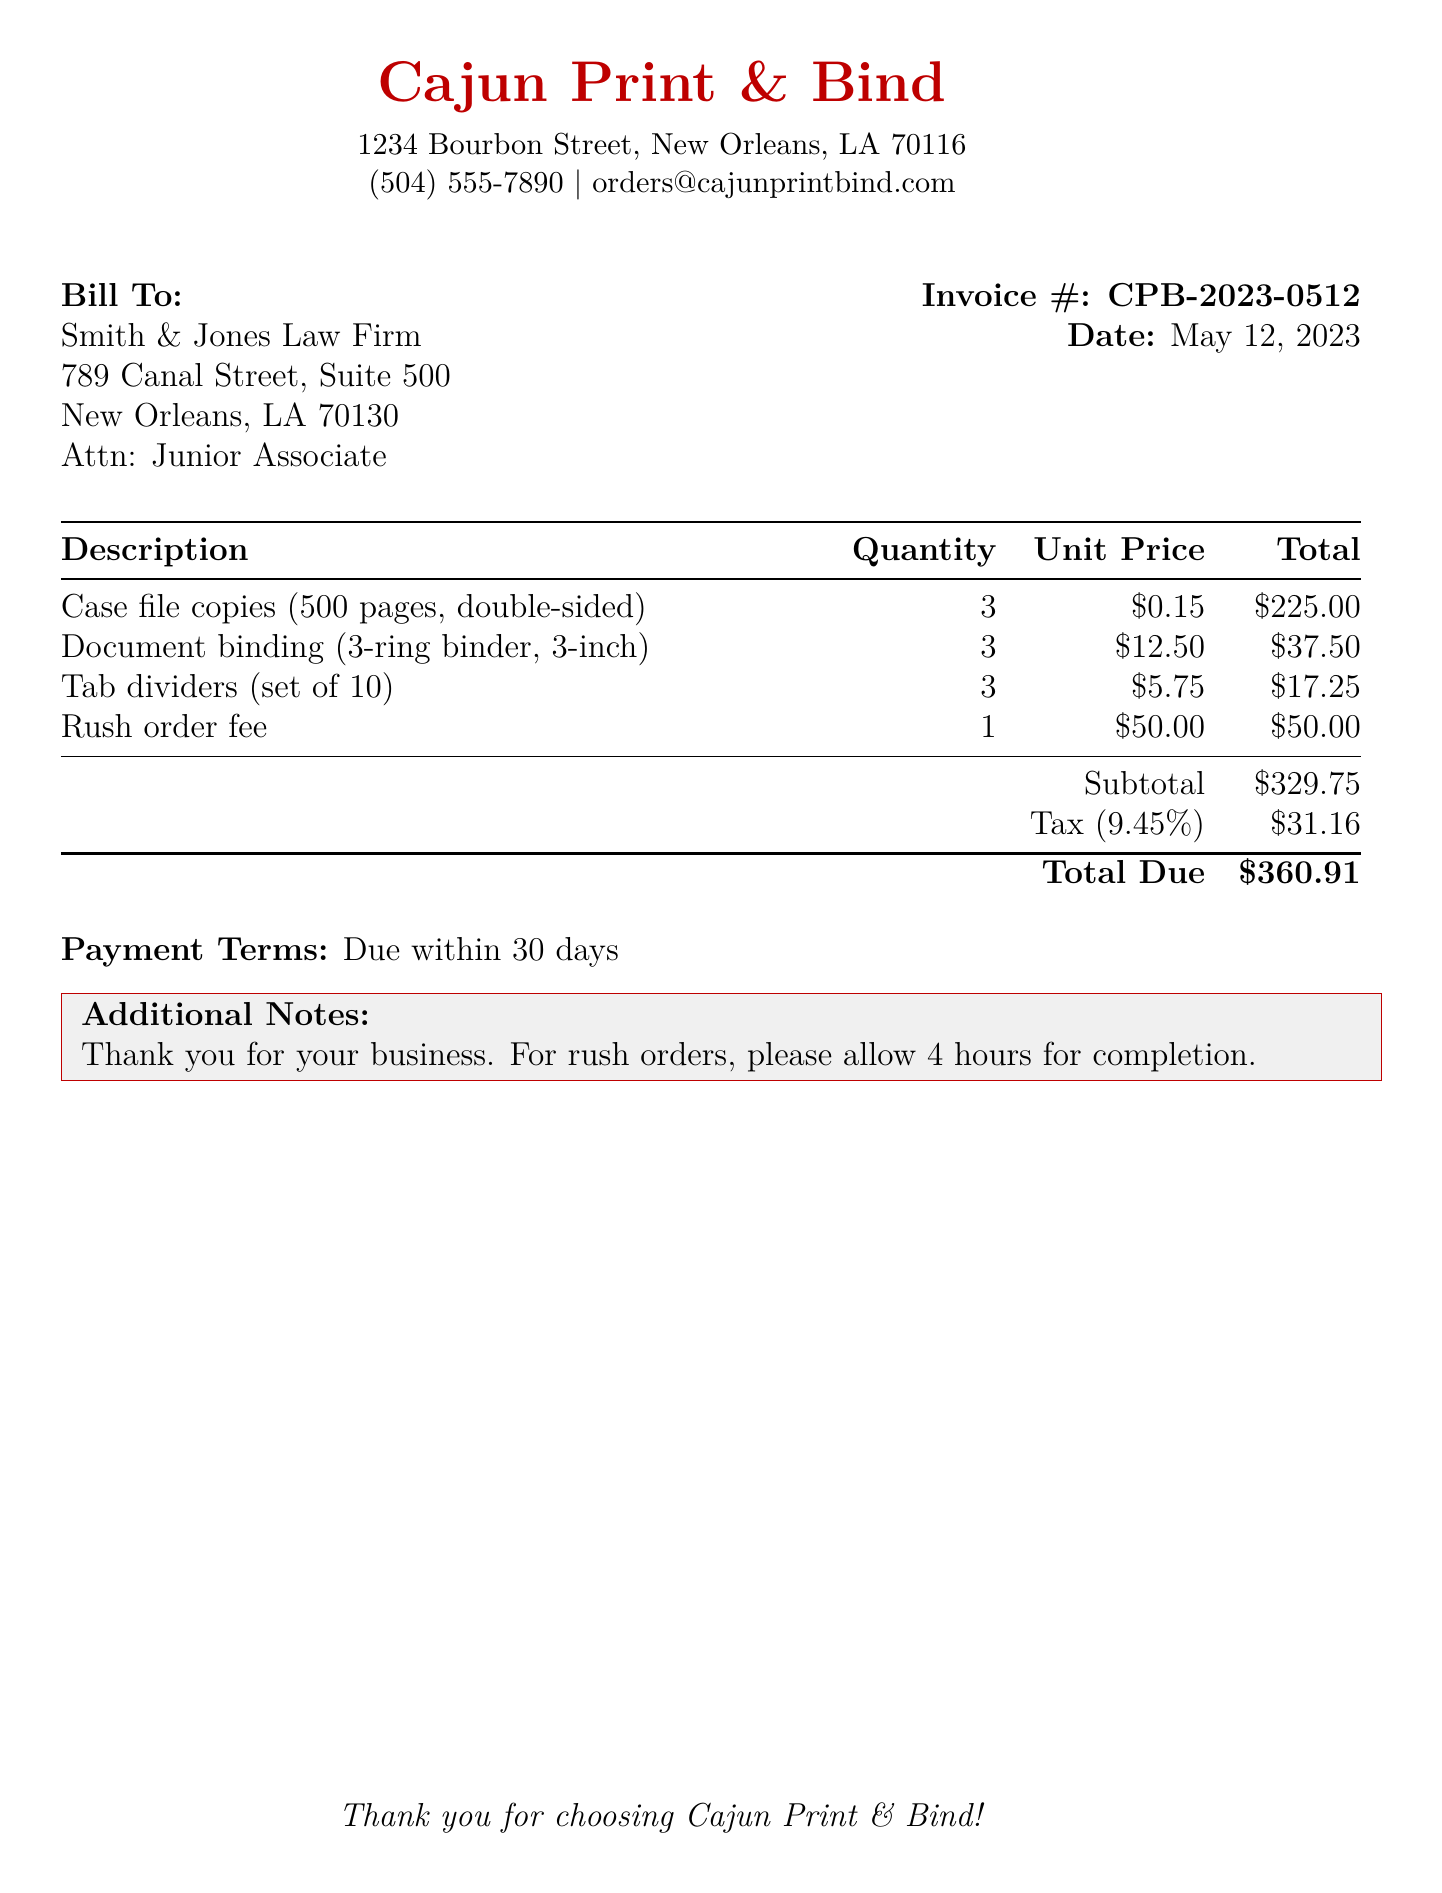what is the invoice number? The invoice number is listed at the top of the bill under "Invoice #."
Answer: CPB-2023-0512 what is the due date for payment? The payment terms specify that the bill is due within 30 days, and the date on the bill is May 12, 2023.
Answer: June 11, 2023 how many case file copies were ordered? The quantity of case file copies is specified in the table of services provided.
Answer: 3 what is the total due amount? The total amount due is listed at the bottom of the bill.
Answer: $360.91 what is the subtotal before tax? The subtotal is calculated by summing individual items listed before the tax section.
Answer: $329.75 what is the tax rate applied? The tax rate is mentioned in the tax line of the bill.
Answer: 9.45% what type of binding is provided for the documents? The description of the binding service indicates the type used.
Answer: 3-ring binder how long should rush orders take for completion? Additional notes section specifies the timeframe for rush orders.
Answer: 4 hours how many tab dividers were ordered? The quantity of tab dividers is listed in the itemized services section.
Answer: 3 